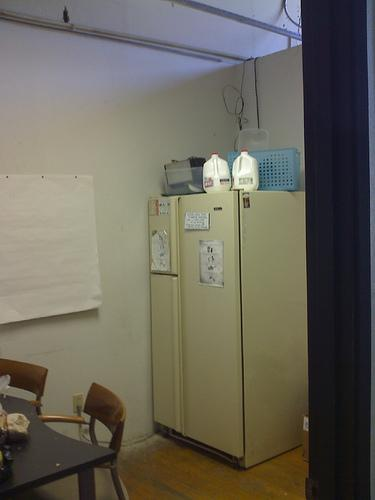Question: who is in the photo?
Choices:
A. 1 person.
B. 2 people.
C. 3 people.
D. No one.
Answer with the letter. Answer: D Question: what color are the chairs?
Choices:
A. White.
B. Green.
C. Brown.
D. Black.
Answer with the letter. Answer: C Question: what room is this?
Choices:
A. Den.
B. Bathroom.
C. Kitchen.
D. Bedroom.
Answer with the letter. Answer: C Question: how many people are there?
Choices:
A. None.
B. One.
C. Five.
D. Seven.
Answer with the letter. Answer: A Question: where was the photo taken?
Choices:
A. A yard.
B. A room.
C. A roof.
D. A road.
Answer with the letter. Answer: B 